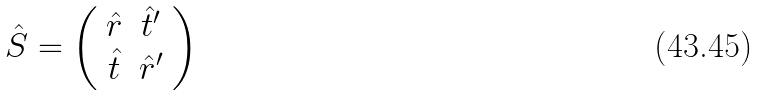<formula> <loc_0><loc_0><loc_500><loc_500>\hat { S } = \left ( \begin{array} { c c } \hat { r } & \hat { t } ^ { \prime } \\ \hat { t } & \hat { r } ^ { \prime } \end{array} \right )</formula> 